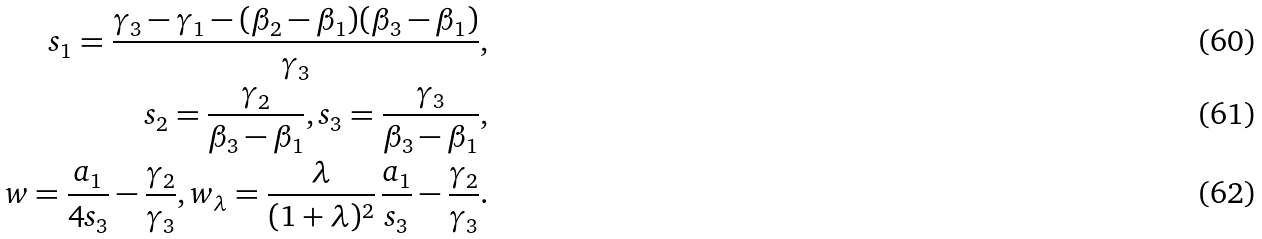<formula> <loc_0><loc_0><loc_500><loc_500>s _ { 1 } = \frac { \gamma _ { 3 } - \gamma _ { 1 } - ( \beta _ { 2 } - \beta _ { 1 } ) ( \beta _ { 3 } - \beta _ { 1 } ) } { \gamma _ { 3 } } , \\ s _ { 2 } = \frac { \gamma _ { 2 } } { \beta _ { 3 } - \beta _ { 1 } } , s _ { 3 } = \frac { \gamma _ { 3 } } { \beta _ { 3 } - \beta _ { 1 } } , \\ w = \frac { a _ { 1 } } { 4 s _ { 3 } } - \frac { \gamma _ { 2 } } { \gamma _ { 3 } } , w _ { \lambda } = \frac { \lambda } { ( 1 + \lambda ) ^ { 2 } } \, \frac { a _ { 1 } } { s _ { 3 } } - \frac { \gamma _ { 2 } } { \gamma _ { 3 } } .</formula> 